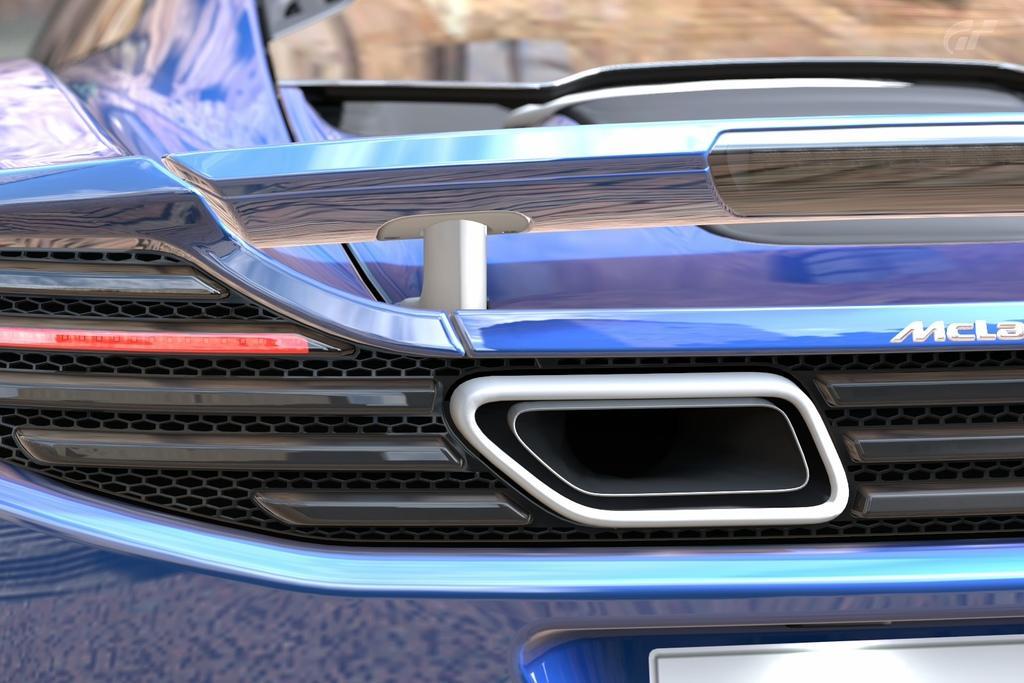How would you summarize this image in a sentence or two? In this image there is a car. 